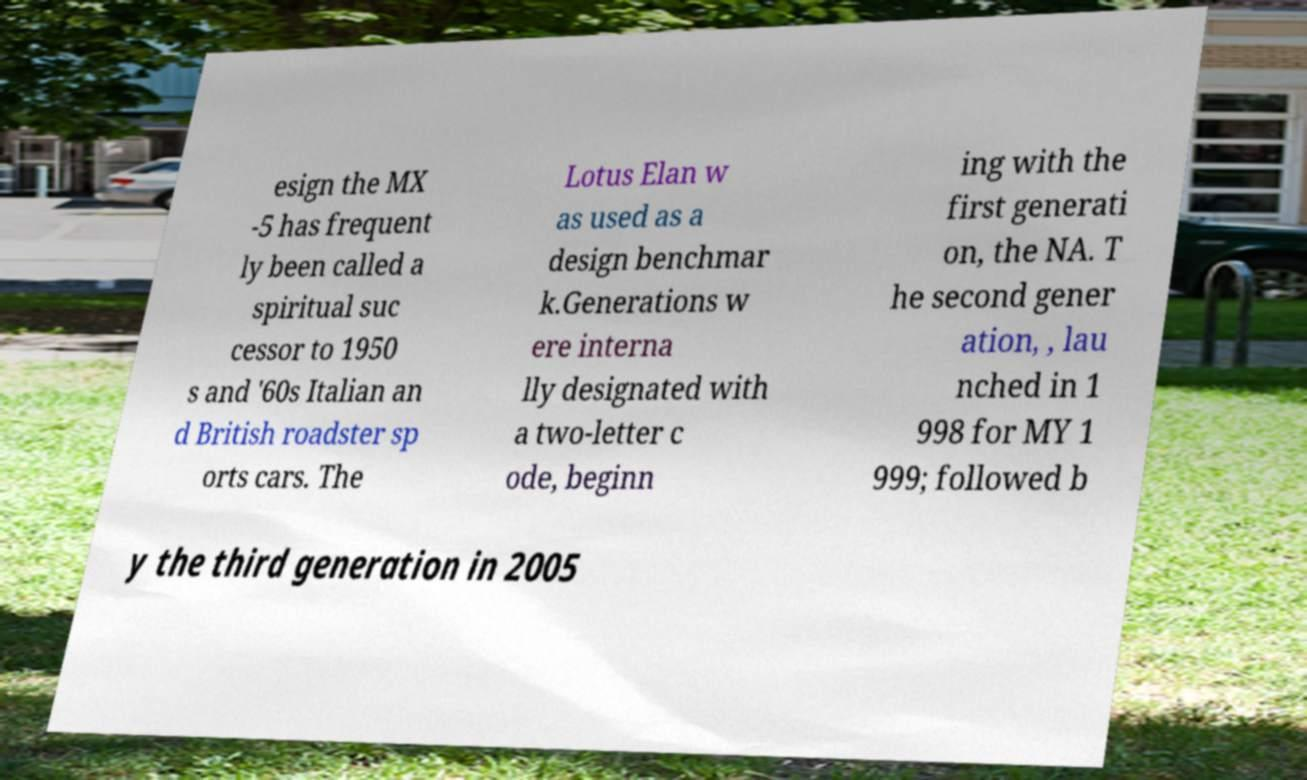Please identify and transcribe the text found in this image. esign the MX -5 has frequent ly been called a spiritual suc cessor to 1950 s and '60s Italian an d British roadster sp orts cars. The Lotus Elan w as used as a design benchmar k.Generations w ere interna lly designated with a two-letter c ode, beginn ing with the first generati on, the NA. T he second gener ation, , lau nched in 1 998 for MY 1 999; followed b y the third generation in 2005 